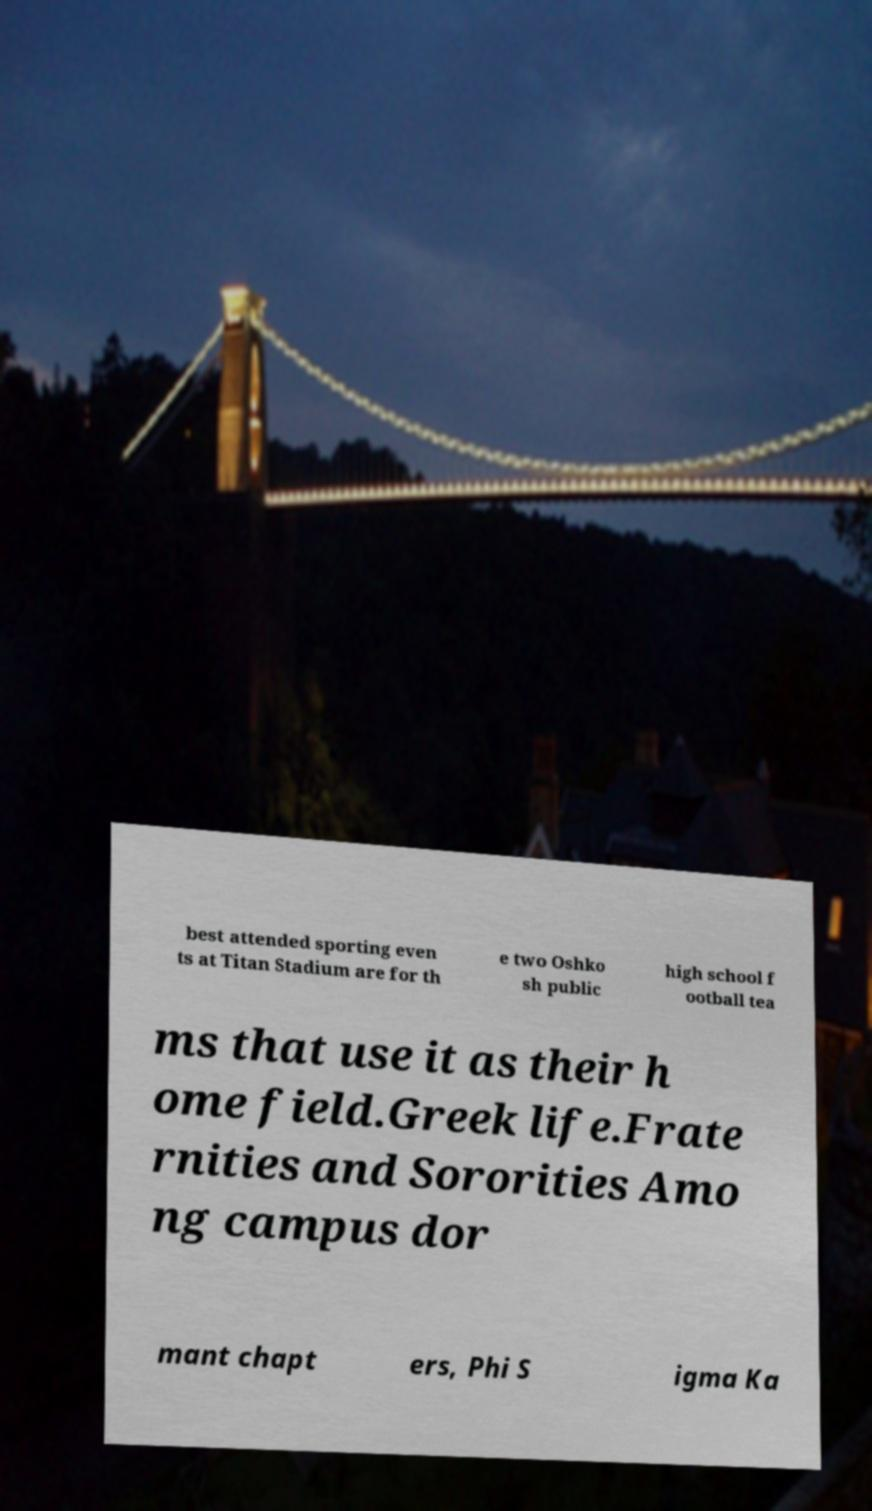Can you accurately transcribe the text from the provided image for me? best attended sporting even ts at Titan Stadium are for th e two Oshko sh public high school f ootball tea ms that use it as their h ome field.Greek life.Frate rnities and Sororities Amo ng campus dor mant chapt ers, Phi S igma Ka 